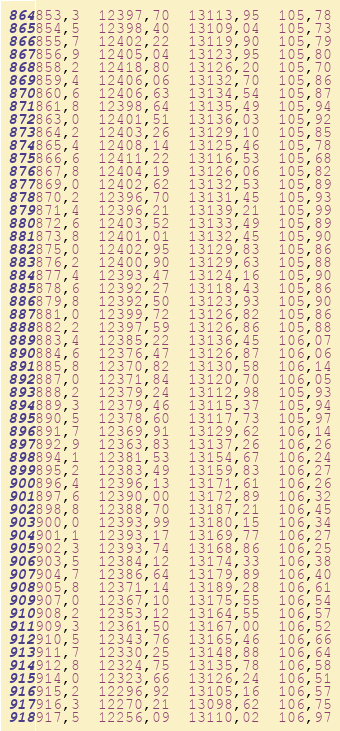Convert code to text. <code><loc_0><loc_0><loc_500><loc_500><_SML_>853,3  12397,70  13113,95  105,78
854,5  12398,40  13109,04  105,73
855,7  12402,22  13119,90  105,79
856,9  12405,04  13123,95  105,80
858,2  12418,80  13126,20  105,70
859,4  12406,06  13132,70  105,86
860,6  12406,63  13134,54  105,87
861,8  12398,64  13135,49  105,94
863,0  12401,51  13136,03  105,92
864,2  12403,26  13129,10  105,85
865,4  12408,14  13125,46  105,78
866,6  12411,22  13116,53  105,68
867,8  12404,19  13126,06  105,82
869,0  12402,62  13132,53  105,89
870,2  12396,70  13131,45  105,93
871,4  12396,21  13139,21  105,99
872,6  12403,52  13133,49  105,89
873,8  12401,01  13132,45  105,90
875,0  12402,95  13129,83  105,86
876,2  12400,90  13129,63  105,88
877,4  12393,47  13124,16  105,90
878,6  12392,27  13118,43  105,86
879,8  12392,50  13123,93  105,90
881,0  12399,72  13126,82  105,86
882,2  12397,59  13126,86  105,88
883,4  12385,22  13136,45  106,07
884,6  12376,47  13126,87  106,06
885,8  12370,82  13130,58  106,14
887,0  12371,84  13120,70  106,05
888,2  12379,24  13112,98  105,93
889,3  12379,46  13115,37  105,94
890,5  12378,60  13117,73  105,97
891,7  12369,91  13129,62  106,14
892,9  12363,83  13137,26  106,26
894,1  12381,53  13154,67  106,24
895,2  12383,49  13159,83  106,27
896,4  12396,13  13171,61  106,26
897,6  12390,00  13172,89  106,32
898,8  12388,70  13187,21  106,45
900,0  12393,99  13180,15  106,34
901,1  12393,17  13169,77  106,27
902,3  12393,74  13168,86  106,25
903,5  12384,12  13174,33  106,38
904,7  12386,64  13179,89  106,40
905,8  12371,14  13189,28  106,61
907,0  12367,10  13175,55  106,54
908,2  12353,12  13164,55  106,57
909,3  12361,50  13167,00  106,52
910,5  12343,76  13165,46  106,66
911,7  12330,25  13148,88  106,64
912,8  12324,75  13135,78  106,58
914,0  12323,66  13126,24  106,51
915,2  12296,92  13105,16  106,57
916,3  12270,21  13098,62  106,75
917,5  12256,09  13110,02  106,97</code> 